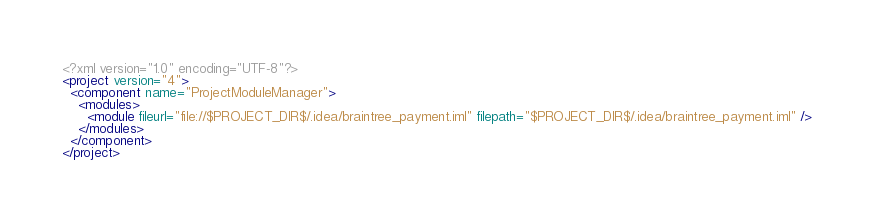Convert code to text. <code><loc_0><loc_0><loc_500><loc_500><_XML_><?xml version="1.0" encoding="UTF-8"?>
<project version="4">
  <component name="ProjectModuleManager">
    <modules>
      <module fileurl="file://$PROJECT_DIR$/.idea/braintree_payment.iml" filepath="$PROJECT_DIR$/.idea/braintree_payment.iml" />
    </modules>
  </component>
</project></code> 